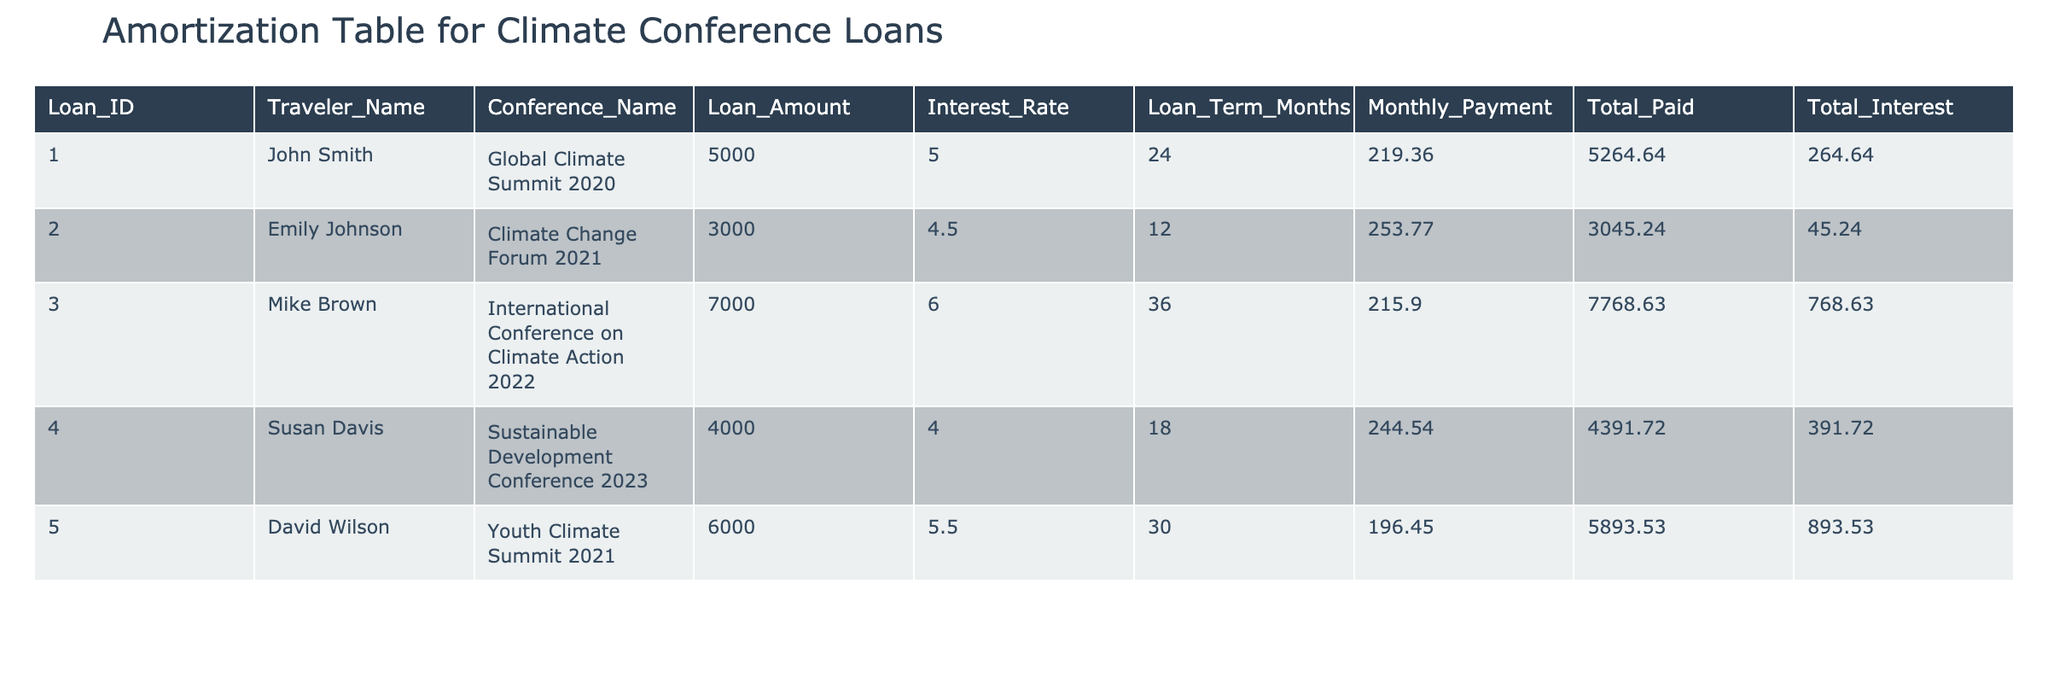What is the loan amount for John Smith? The table shows that John Smith's loan amount is listed in the "Loan_Amount" column under his name. It is 5000.
Answer: 5000 What is the interest rate for the loan taken for the Sustainable Development Conference 2023? Looking in the "Interest_Rate" column next to the "Sustainable Development Conference 2023" row, the interest rate is 4.0%.
Answer: 4.0% Which traveler has the highest total interest paid on their loan? To determine this, we compare the "Total_Interest" column values: John Smith pays 264.64, Emily Johnson pays 45.24, Mike Brown pays 768.63, Susan Davis pays 391.72, and David Wilson pays 893.53. David Wilson has the highest total interest paid.
Answer: David Wilson What is the average loan amount among all the travelers? To find the average loan amount, sum all loan amounts: 5000 + 3000 + 7000 + 4000 + 6000 = 25000. Then, divide by the number of loans (5), which gives 25000 / 5 = 5000.
Answer: 5000 Is the total amount paid for the Climate Change Forum 2021 greater than the loan amount? For Climate Change Forum 2021, the "Total_Paid" is 3045.24, and the "Loan_Amount" is 3000. Since 3045.24 is greater than 3000, the statement is true.
Answer: Yes What is the total amount paid for all loans together? To find the total of all amounts paid, we need to sum the "Total_Paid" values: 5264.64 + 3045.24 + 7768.63 + 4391.72 + 5893.53 = 26363.76.
Answer: 26363.76 How many travelers have a loan term of more than 24 months? Checking the "Loan_Term_Months" column, the values are 24, 12, 36, 18, and 30. The travelers with loan terms more than 24 months are Mike Brown (36 months) and David Wilson (30 months), totaling 2 travelers.
Answer: 2 If we exclude the loans with an interest rate lower than 5%, what is the total interest paid by the remaining loans? The loans with interest rates of 5% or higher are for John Smith (264.64), Mike Brown (768.63), and David Wilson (893.53). Adding these values gives: 264.64 + 768.63 + 893.53 = 1926.80.
Answer: 1926.80 What is the name of the traveler with the shortest loan term? The shortest loan term is 12 months from the Climate Change Forum 2021, which is taken by Emily Johnson.
Answer: Emily Johnson 